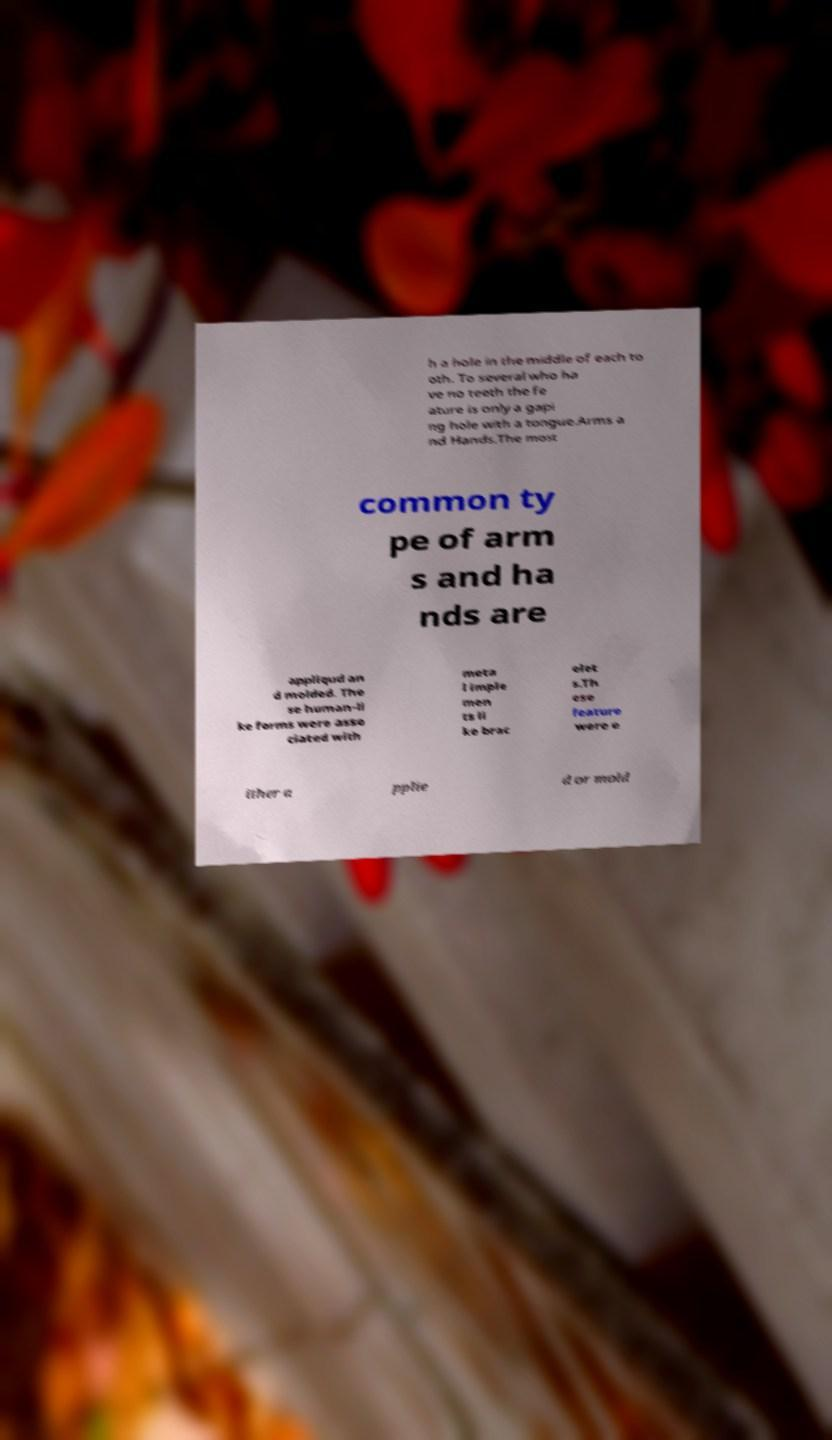Please identify and transcribe the text found in this image. h a hole in the middle of each to oth. To several who ha ve no teeth the fe ature is only a gapi ng hole with a tongue.Arms a nd Hands.The most common ty pe of arm s and ha nds are appliqud an d molded. The se human-li ke forms were asso ciated with meta l imple men ts li ke brac elet s.Th ese feature were e ither a pplie d or mold 